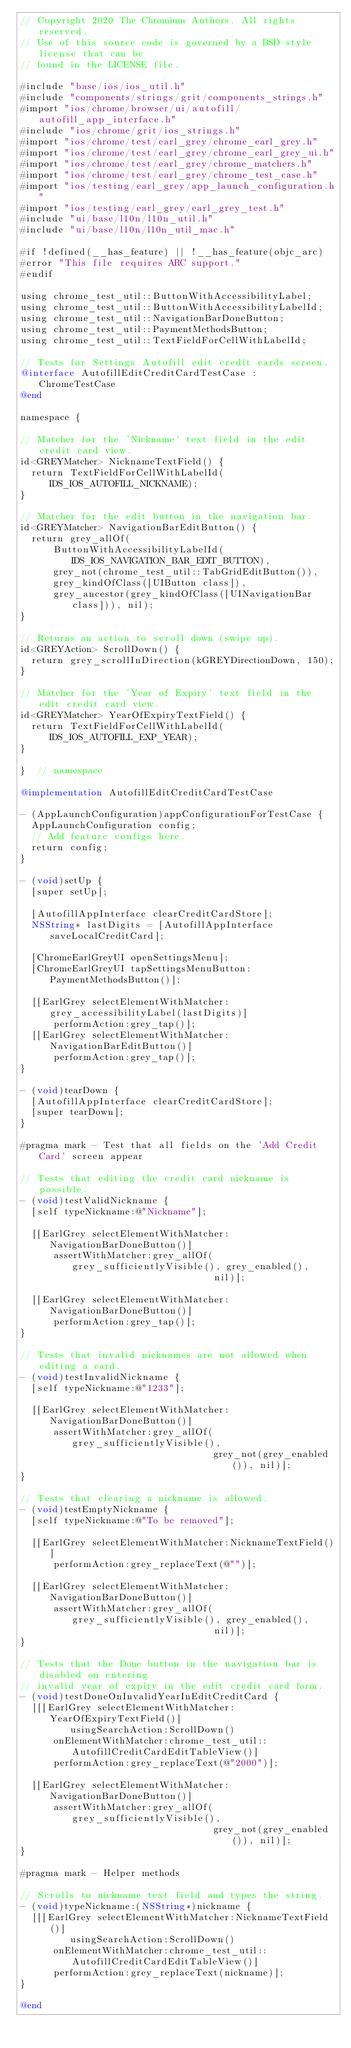Convert code to text. <code><loc_0><loc_0><loc_500><loc_500><_ObjectiveC_>// Copyright 2020 The Chromium Authors. All rights reserved.
// Use of this source code is governed by a BSD-style license that can be
// found in the LICENSE file.

#include "base/ios/ios_util.h"
#include "components/strings/grit/components_strings.h"
#import "ios/chrome/browser/ui/autofill/autofill_app_interface.h"
#include "ios/chrome/grit/ios_strings.h"
#import "ios/chrome/test/earl_grey/chrome_earl_grey.h"
#import "ios/chrome/test/earl_grey/chrome_earl_grey_ui.h"
#import "ios/chrome/test/earl_grey/chrome_matchers.h"
#import "ios/chrome/test/earl_grey/chrome_test_case.h"
#import "ios/testing/earl_grey/app_launch_configuration.h"
#import "ios/testing/earl_grey/earl_grey_test.h"
#include "ui/base/l10n/l10n_util.h"
#include "ui/base/l10n/l10n_util_mac.h"

#if !defined(__has_feature) || !__has_feature(objc_arc)
#error "This file requires ARC support."
#endif

using chrome_test_util::ButtonWithAccessibilityLabel;
using chrome_test_util::ButtonWithAccessibilityLabelId;
using chrome_test_util::NavigationBarDoneButton;
using chrome_test_util::PaymentMethodsButton;
using chrome_test_util::TextFieldForCellWithLabelId;

// Tests for Settings Autofill edit credit cards screen.
@interface AutofillEditCreditCardTestCase : ChromeTestCase
@end

namespace {

// Matcher for the 'Nickname' text field in the edit credit card view.
id<GREYMatcher> NicknameTextField() {
  return TextFieldForCellWithLabelId(IDS_IOS_AUTOFILL_NICKNAME);
}

// Matcher for the edit button in the navigation bar.
id<GREYMatcher> NavigationBarEditButton() {
  return grey_allOf(
      ButtonWithAccessibilityLabelId(IDS_IOS_NAVIGATION_BAR_EDIT_BUTTON),
      grey_not(chrome_test_util::TabGridEditButton()),
      grey_kindOfClass([UIButton class]),
      grey_ancestor(grey_kindOfClass([UINavigationBar class])), nil);
}

// Returns an action to scroll down (swipe up).
id<GREYAction> ScrollDown() {
  return grey_scrollInDirection(kGREYDirectionDown, 150);
}

// Matcher for the 'Year of Expiry' text field in the edit credit card view.
id<GREYMatcher> YearOfExpiryTextField() {
  return TextFieldForCellWithLabelId(IDS_IOS_AUTOFILL_EXP_YEAR);
}

}  // namespace

@implementation AutofillEditCreditCardTestCase

- (AppLaunchConfiguration)appConfigurationForTestCase {
  AppLaunchConfiguration config;
  // Add feature configs here.
  return config;
}

- (void)setUp {
  [super setUp];

  [AutofillAppInterface clearCreditCardStore];
  NSString* lastDigits = [AutofillAppInterface saveLocalCreditCard];

  [ChromeEarlGreyUI openSettingsMenu];
  [ChromeEarlGreyUI tapSettingsMenuButton:PaymentMethodsButton()];

  [[EarlGrey selectElementWithMatcher:grey_accessibilityLabel(lastDigits)]
      performAction:grey_tap()];
  [[EarlGrey selectElementWithMatcher:NavigationBarEditButton()]
      performAction:grey_tap()];
}

- (void)tearDown {
  [AutofillAppInterface clearCreditCardStore];
  [super tearDown];
}

#pragma mark - Test that all fields on the 'Add Credit Card' screen appear

// Tests that editing the credit card nickname is possible.
- (void)testValidNickname {
  [self typeNickname:@"Nickname"];

  [[EarlGrey selectElementWithMatcher:NavigationBarDoneButton()]
      assertWithMatcher:grey_allOf(grey_sufficientlyVisible(), grey_enabled(),
                                   nil)];

  [[EarlGrey selectElementWithMatcher:NavigationBarDoneButton()]
      performAction:grey_tap()];
}

// Tests that invalid nicknames are not allowed when editing a card.
- (void)testInvalidNickname {
  [self typeNickname:@"1233"];

  [[EarlGrey selectElementWithMatcher:NavigationBarDoneButton()]
      assertWithMatcher:grey_allOf(grey_sufficientlyVisible(),
                                   grey_not(grey_enabled()), nil)];
}

// Tests that clearing a nickname is allowed.
- (void)testEmptyNickname {
  [self typeNickname:@"To be removed"];

  [[EarlGrey selectElementWithMatcher:NicknameTextField()]
      performAction:grey_replaceText(@"")];

  [[EarlGrey selectElementWithMatcher:NavigationBarDoneButton()]
      assertWithMatcher:grey_allOf(grey_sufficientlyVisible(), grey_enabled(),
                                   nil)];
}

// Tests that the Done button in the navigation bar is disabled on entering
// invalid year of expiry in the edit credit card form.
- (void)testDoneOnInvalidYearInEditCreditCard {
  [[[EarlGrey selectElementWithMatcher:YearOfExpiryTextField()]
         usingSearchAction:ScrollDown()
      onElementWithMatcher:chrome_test_util::AutofillCreditCardEditTableView()]
      performAction:grey_replaceText(@"2000")];

  [[EarlGrey selectElementWithMatcher:NavigationBarDoneButton()]
      assertWithMatcher:grey_allOf(grey_sufficientlyVisible(),
                                   grey_not(grey_enabled()), nil)];
}

#pragma mark - Helper methods

// Scrolls to nickname text field and types the string.
- (void)typeNickname:(NSString*)nickname {
  [[[EarlGrey selectElementWithMatcher:NicknameTextField()]
         usingSearchAction:ScrollDown()
      onElementWithMatcher:chrome_test_util::AutofillCreditCardEditTableView()]
      performAction:grey_replaceText(nickname)];
}

@end
</code> 